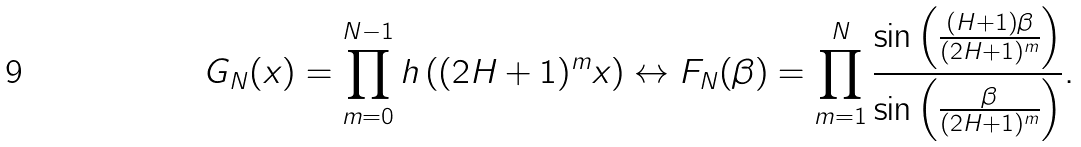Convert formula to latex. <formula><loc_0><loc_0><loc_500><loc_500>G _ { N } ( x ) = \prod _ { m = 0 } ^ { N - 1 } h \left ( ( 2 H + 1 ) ^ { m } x \right ) \leftrightarrow F _ { N } ( \beta ) = \prod _ { m = 1 } ^ { N } \frac { \sin \left ( \frac { ( H + 1 ) \beta } { ( 2 H + 1 ) ^ { m } } \right ) } { \sin \left ( \frac { \beta } { ( 2 H + 1 ) ^ { m } } \right ) } .</formula> 